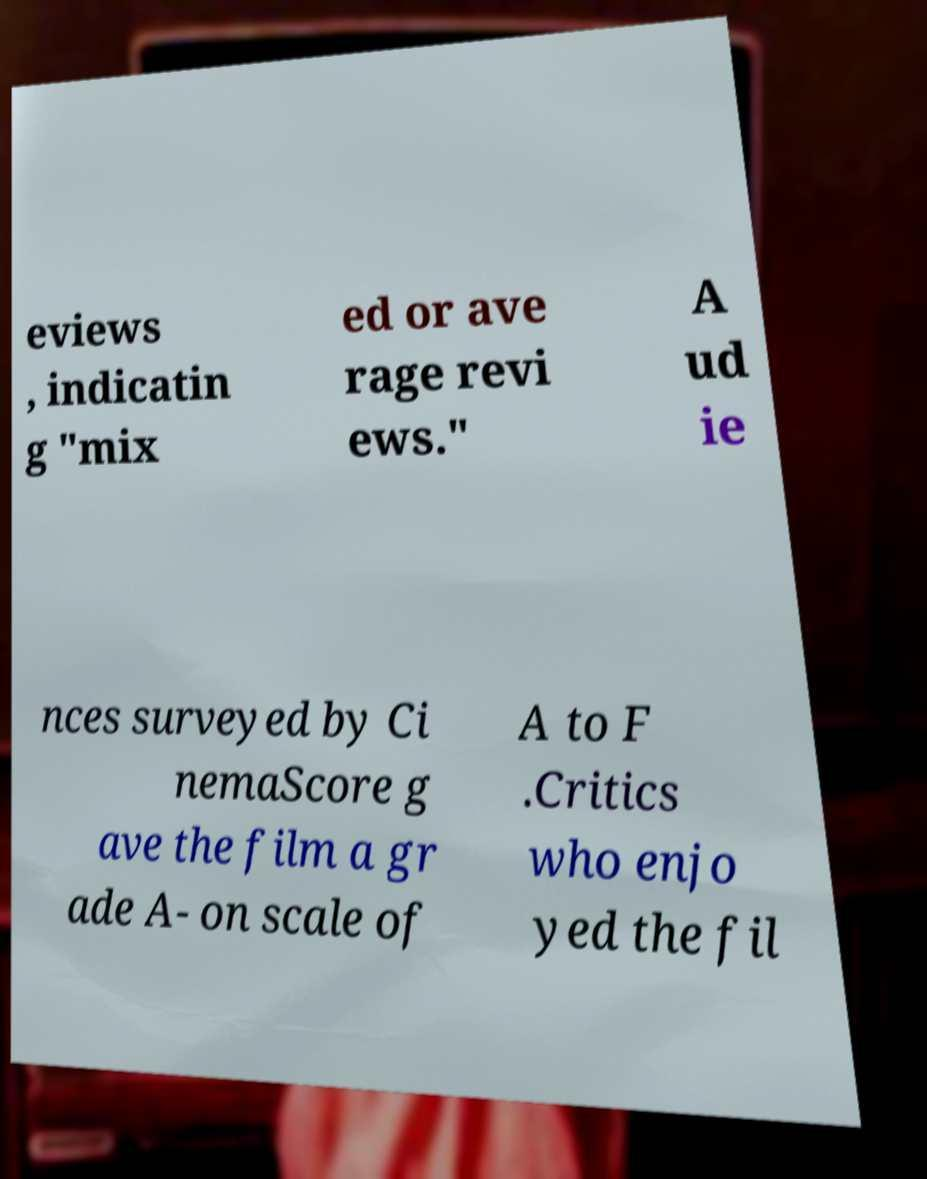Can you accurately transcribe the text from the provided image for me? eviews , indicatin g "mix ed or ave rage revi ews." A ud ie nces surveyed by Ci nemaScore g ave the film a gr ade A- on scale of A to F .Critics who enjo yed the fil 